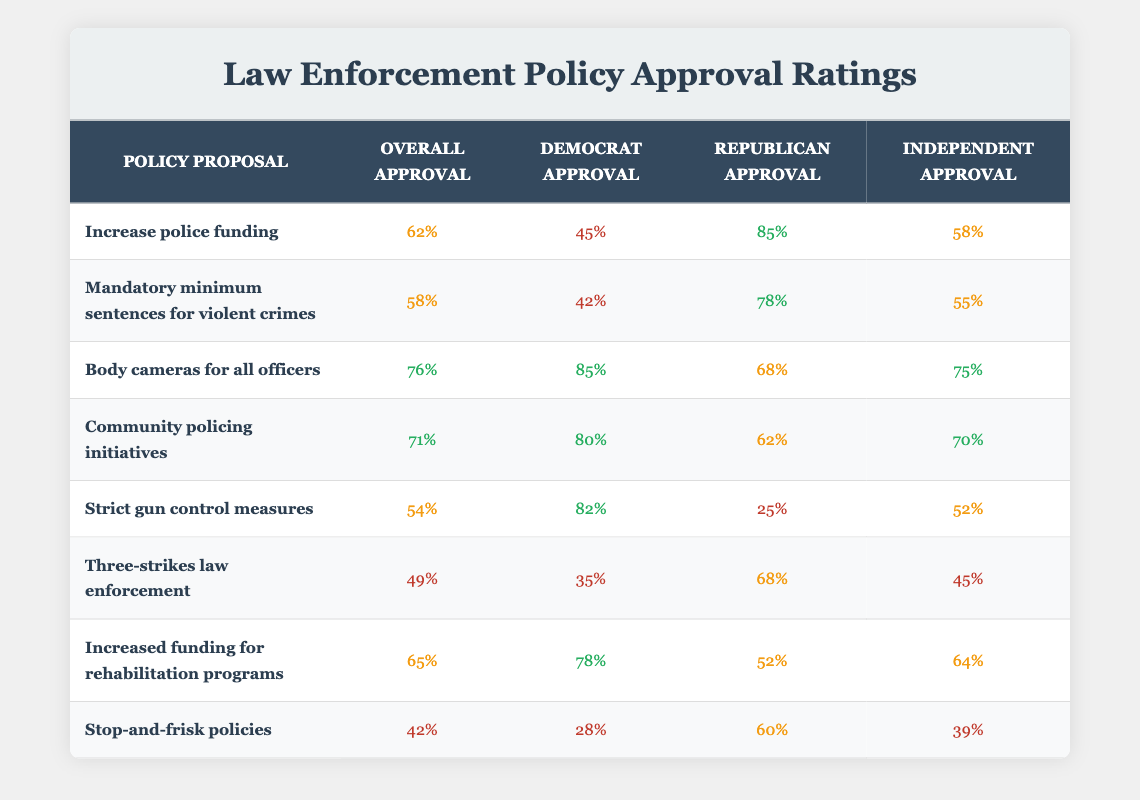What is the overall approval rating for "Body cameras for all officers"? The overall approval rating can be found in the table under the "Overall Approval" column for the proposal "Body cameras for all officers," which is 76%.
Answer: 76% Which policy proposal has the highest approval among Democrats? The table shows that "Body cameras for all officers" has the highest Democrat approval at 85%.
Answer: 85% What is the difference in Republican approval between "Increase police funding" and "Three-strikes law enforcement"? The Republican approval for "Increase police funding" is 85%, and for "Three-strikes law enforcement," it is 68%. The difference is calculated as (85 - 68) = 17%.
Answer: 17% Do more Independents approve of "Strict gun control measures" or "Community policing initiatives"? "Strict gun control measures" has an independent approval rating of 52%, and "Community policing initiatives" has a rating of 70%. Since 70% is greater than 52%, more Independents approve of "Community policing initiatives."
Answer: Yes Which policy proposal has the lowest overall approval rating? By checking the "Overall Approval" column, "Stop-and-frisk policies" has the lowest rating at 42%.
Answer: 42% If we consider only the Republican approvals, which proposal has the lowest approval rating? The Republican approvals for each proposal are checked: "Stop-and-frisk policies" has the lowest approval among Republicans at 60%.
Answer: 60% What is the average overall approval rating of all the proposed policies? The overall approvals are: 62, 58, 76, 71, 54, 49, 65, and 42. Sum them up to get (62 + 58 + 76 + 71 + 54 + 49 + 65 + 42) = 477. There are 8 proposals, so the average is 477/8 = 59.625, which can be rounded to 60%.
Answer: 60% Is it true that the approval rating for "Increased funding for rehabilitation programs" is higher than that for "Mandatory minimum sentences for violent crimes"? "Increased funding for rehabilitation programs" has an overall approval of 65%, while "Mandatory minimum sentences for violent crimes" has 58%. Since 65% is greater than 58%, it is true.
Answer: Yes What percentage of Democrats approve of "Three-strikes law enforcement"? The table states that the Democrat approval for "Three-strikes law enforcement" is 35%.
Answer: 35% 